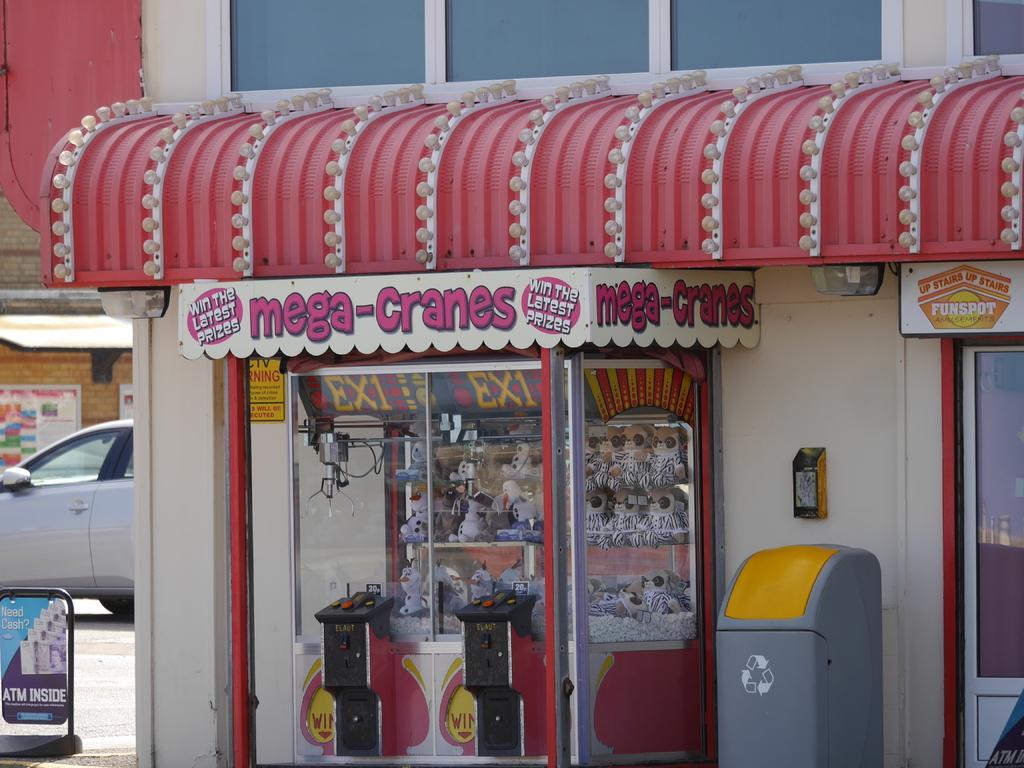In one or two sentences, can you explain what this image depicts? In this image I can see the dustbin and the building with boards. To the left I can see the board, vehicle on the road and an another building with boards. 